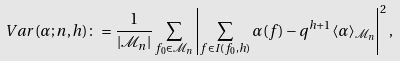<formula> <loc_0><loc_0><loc_500><loc_500>V a r ( \alpha ; n , h ) \colon = \frac { 1 } { \left | \mathcal { M } _ { n } \right | } \sum _ { f _ { 0 } \in \mathcal { M } _ { n } } \left | \sum _ { f \in I ( f _ { 0 } , h ) } \alpha ( f ) - q ^ { h + 1 } \langle \alpha \rangle _ { \mathcal { M } _ { n } } \right | ^ { 2 } ,</formula> 